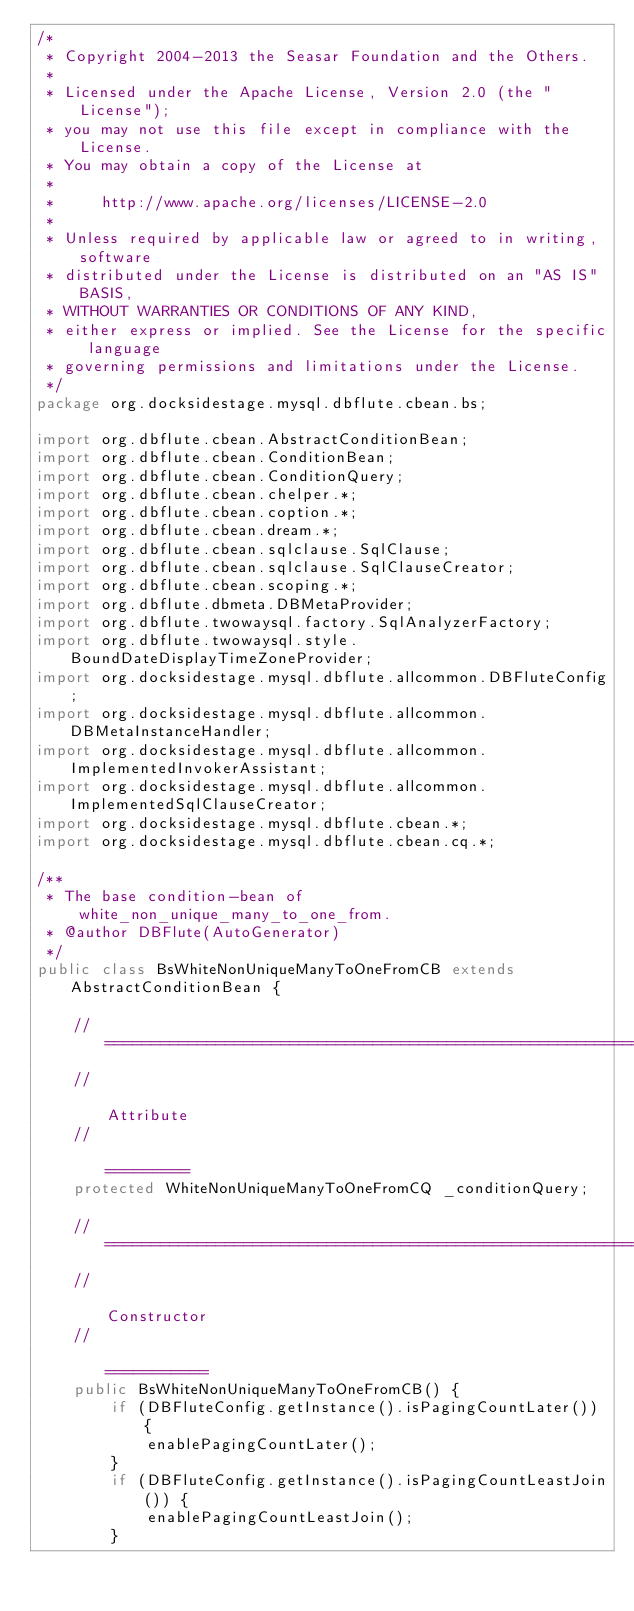Convert code to text. <code><loc_0><loc_0><loc_500><loc_500><_Java_>/*
 * Copyright 2004-2013 the Seasar Foundation and the Others.
 *
 * Licensed under the Apache License, Version 2.0 (the "License");
 * you may not use this file except in compliance with the License.
 * You may obtain a copy of the License at
 *
 *     http://www.apache.org/licenses/LICENSE-2.0
 *
 * Unless required by applicable law or agreed to in writing, software
 * distributed under the License is distributed on an "AS IS" BASIS,
 * WITHOUT WARRANTIES OR CONDITIONS OF ANY KIND,
 * either express or implied. See the License for the specific language
 * governing permissions and limitations under the License.
 */
package org.docksidestage.mysql.dbflute.cbean.bs;

import org.dbflute.cbean.AbstractConditionBean;
import org.dbflute.cbean.ConditionBean;
import org.dbflute.cbean.ConditionQuery;
import org.dbflute.cbean.chelper.*;
import org.dbflute.cbean.coption.*;
import org.dbflute.cbean.dream.*;
import org.dbflute.cbean.sqlclause.SqlClause;
import org.dbflute.cbean.sqlclause.SqlClauseCreator;
import org.dbflute.cbean.scoping.*;
import org.dbflute.dbmeta.DBMetaProvider;
import org.dbflute.twowaysql.factory.SqlAnalyzerFactory;
import org.dbflute.twowaysql.style.BoundDateDisplayTimeZoneProvider;
import org.docksidestage.mysql.dbflute.allcommon.DBFluteConfig;
import org.docksidestage.mysql.dbflute.allcommon.DBMetaInstanceHandler;
import org.docksidestage.mysql.dbflute.allcommon.ImplementedInvokerAssistant;
import org.docksidestage.mysql.dbflute.allcommon.ImplementedSqlClauseCreator;
import org.docksidestage.mysql.dbflute.cbean.*;
import org.docksidestage.mysql.dbflute.cbean.cq.*;

/**
 * The base condition-bean of white_non_unique_many_to_one_from.
 * @author DBFlute(AutoGenerator)
 */
public class BsWhiteNonUniqueManyToOneFromCB extends AbstractConditionBean {

    // ===================================================================================
    //                                                                           Attribute
    //                                                                           =========
    protected WhiteNonUniqueManyToOneFromCQ _conditionQuery;

    // ===================================================================================
    //                                                                         Constructor
    //                                                                         ===========
    public BsWhiteNonUniqueManyToOneFromCB() {
        if (DBFluteConfig.getInstance().isPagingCountLater()) {
            enablePagingCountLater();
        }
        if (DBFluteConfig.getInstance().isPagingCountLeastJoin()) {
            enablePagingCountLeastJoin();
        }</code> 